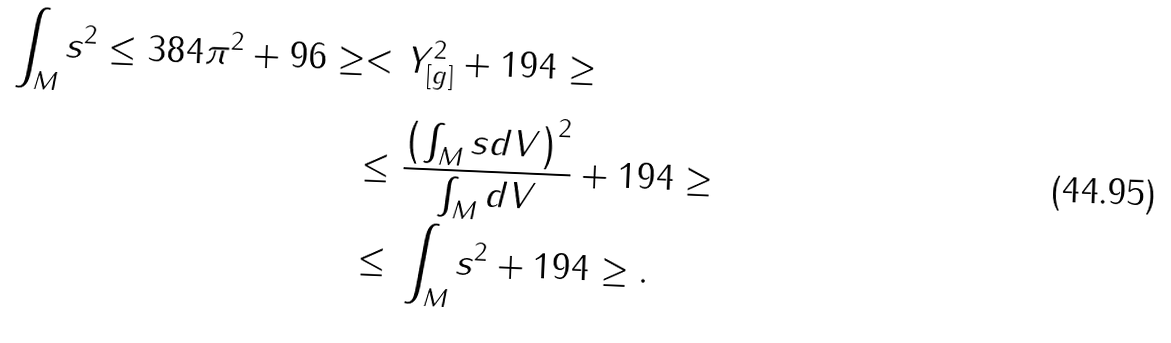<formula> <loc_0><loc_0><loc_500><loc_500>\int _ { M } s ^ { 2 } \leq 3 8 4 \pi ^ { 2 } + 9 6 \geq < & \ Y _ { [ g ] } ^ { 2 } + 1 9 4 \geq \\ \leq & \ \frac { \left ( \int _ { M } s d V \right ) ^ { 2 } } { \int _ { M } d V } + 1 9 4 \geq \\ \leq & \ \int _ { M } s ^ { 2 } + 1 9 4 \geq .</formula> 